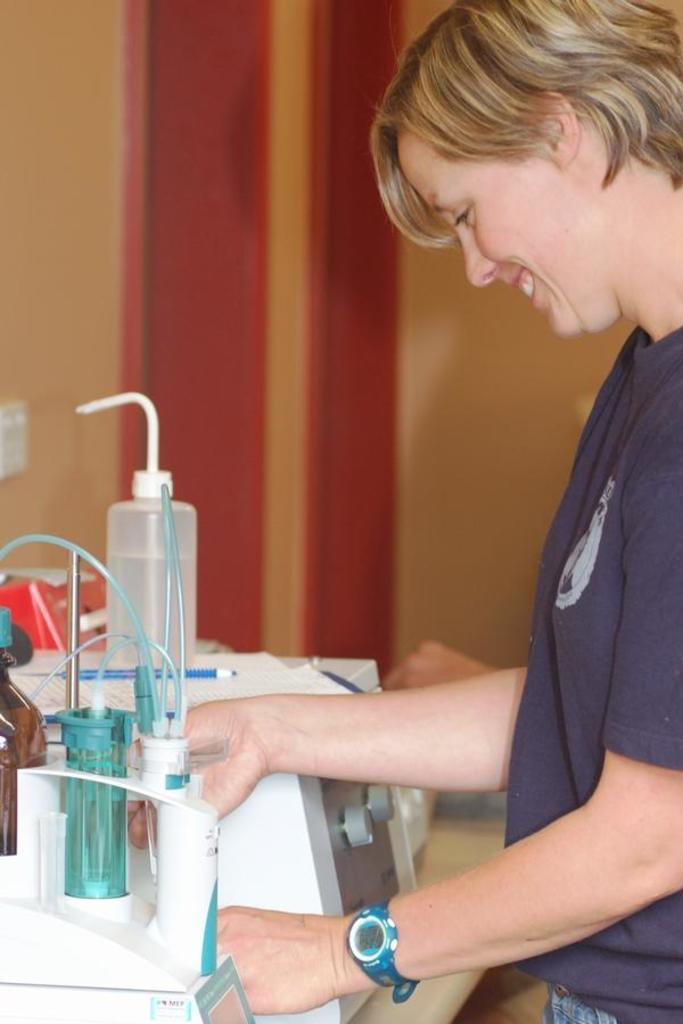How would you summarize this image in a sentence or two? Here in this picture on the right side we can see a woman standing over a place and we can see she is smiling and in front of her we can see a table, on which we can see some equipments present and we can see she is handling one of the equipment present and we can also see some papers and pen also present on the equipment. 